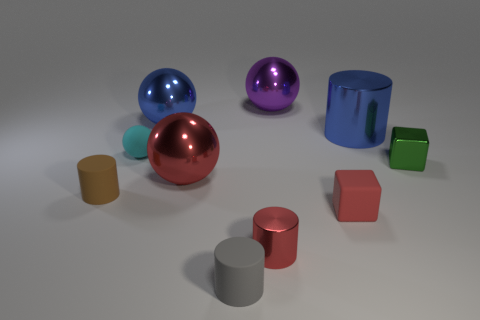Subtract all big metallic cylinders. How many cylinders are left? 3 Subtract 3 balls. How many balls are left? 1 Subtract all red cylinders. How many cylinders are left? 3 Subtract all blocks. How many objects are left? 8 Add 9 tiny cyan things. How many tiny cyan things are left? 10 Add 8 small red rubber cubes. How many small red rubber cubes exist? 9 Subtract 0 gray blocks. How many objects are left? 10 Subtract all green spheres. Subtract all red cylinders. How many spheres are left? 4 Subtract all blue shiny blocks. Subtract all big red things. How many objects are left? 9 